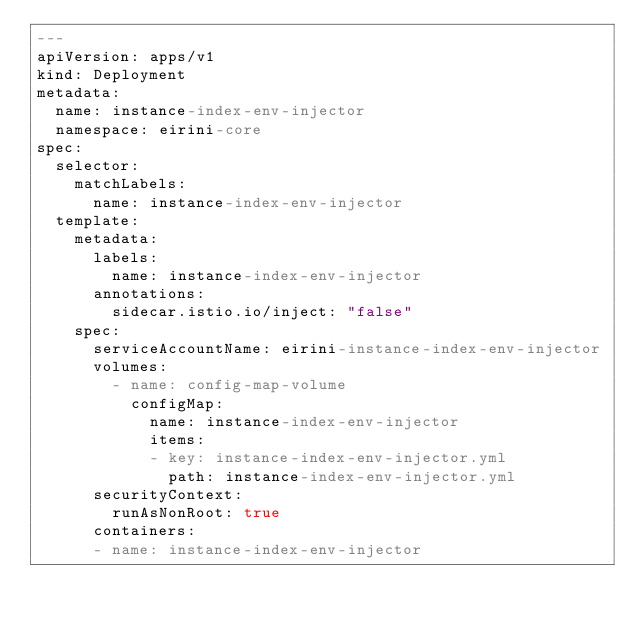<code> <loc_0><loc_0><loc_500><loc_500><_YAML_>---
apiVersion: apps/v1
kind: Deployment
metadata:
  name: instance-index-env-injector
  namespace: eirini-core
spec:
  selector:
    matchLabels:
      name: instance-index-env-injector
  template:
    metadata:
      labels:
        name: instance-index-env-injector
      annotations:
        sidecar.istio.io/inject: "false"
    spec:
      serviceAccountName: eirini-instance-index-env-injector
      volumes:
        - name: config-map-volume
          configMap:
            name: instance-index-env-injector
            items:
            - key: instance-index-env-injector.yml
              path: instance-index-env-injector.yml
      securityContext:
        runAsNonRoot: true
      containers:
      - name: instance-index-env-injector</code> 